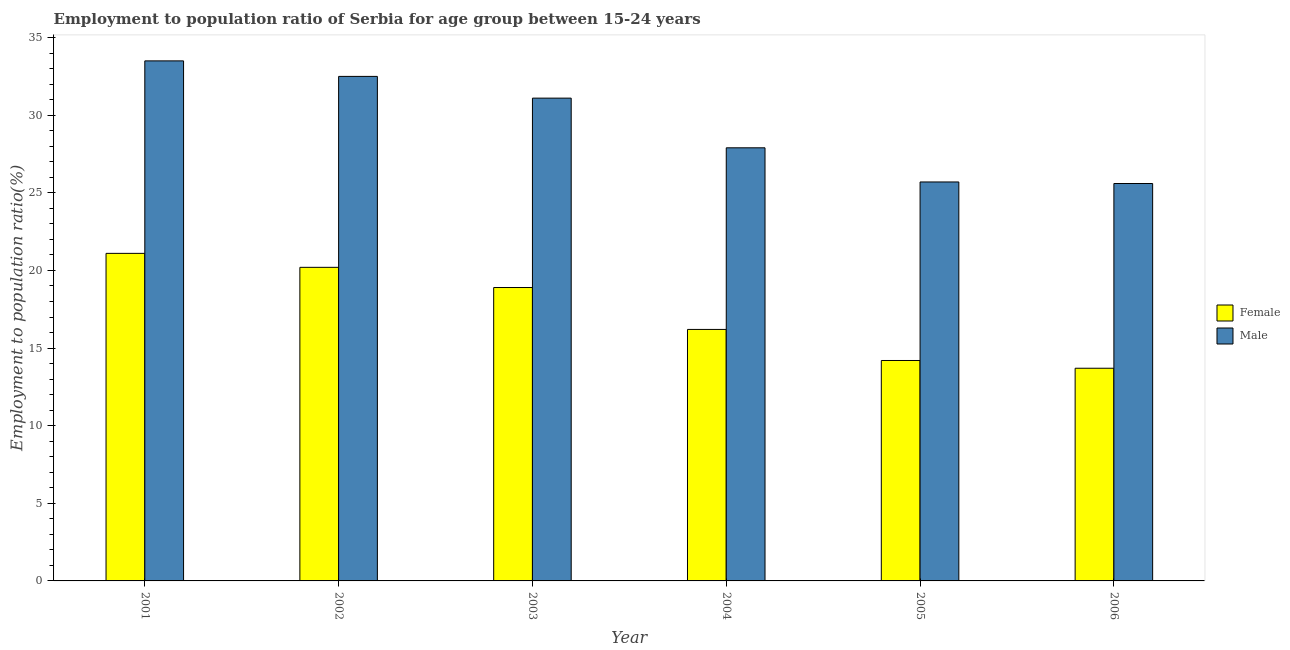Are the number of bars per tick equal to the number of legend labels?
Offer a terse response. Yes. Are the number of bars on each tick of the X-axis equal?
Offer a very short reply. Yes. How many bars are there on the 3rd tick from the right?
Provide a succinct answer. 2. In how many cases, is the number of bars for a given year not equal to the number of legend labels?
Offer a terse response. 0. What is the employment to population ratio(female) in 2001?
Give a very brief answer. 21.1. Across all years, what is the maximum employment to population ratio(male)?
Your answer should be compact. 33.5. Across all years, what is the minimum employment to population ratio(male)?
Provide a short and direct response. 25.6. What is the total employment to population ratio(female) in the graph?
Your response must be concise. 104.3. What is the difference between the employment to population ratio(female) in 2005 and the employment to population ratio(male) in 2006?
Your response must be concise. 0.5. What is the average employment to population ratio(female) per year?
Offer a very short reply. 17.38. In the year 2001, what is the difference between the employment to population ratio(female) and employment to population ratio(male)?
Keep it short and to the point. 0. What is the ratio of the employment to population ratio(male) in 2001 to that in 2002?
Offer a terse response. 1.03. Is the employment to population ratio(male) in 2002 less than that in 2005?
Give a very brief answer. No. Is the difference between the employment to population ratio(male) in 2001 and 2002 greater than the difference between the employment to population ratio(female) in 2001 and 2002?
Keep it short and to the point. No. What is the difference between the highest and the second highest employment to population ratio(female)?
Keep it short and to the point. 0.9. What is the difference between the highest and the lowest employment to population ratio(male)?
Your answer should be compact. 7.9. Is the sum of the employment to population ratio(male) in 2003 and 2006 greater than the maximum employment to population ratio(female) across all years?
Give a very brief answer. Yes. What does the 1st bar from the left in 2001 represents?
Your answer should be very brief. Female. Does the graph contain any zero values?
Your answer should be very brief. No. Does the graph contain grids?
Your answer should be compact. No. How are the legend labels stacked?
Offer a terse response. Vertical. What is the title of the graph?
Provide a succinct answer. Employment to population ratio of Serbia for age group between 15-24 years. Does "GDP" appear as one of the legend labels in the graph?
Offer a terse response. No. What is the label or title of the X-axis?
Ensure brevity in your answer.  Year. What is the Employment to population ratio(%) in Female in 2001?
Ensure brevity in your answer.  21.1. What is the Employment to population ratio(%) of Male in 2001?
Offer a very short reply. 33.5. What is the Employment to population ratio(%) in Female in 2002?
Your answer should be very brief. 20.2. What is the Employment to population ratio(%) of Male in 2002?
Provide a succinct answer. 32.5. What is the Employment to population ratio(%) of Female in 2003?
Provide a short and direct response. 18.9. What is the Employment to population ratio(%) in Male in 2003?
Offer a very short reply. 31.1. What is the Employment to population ratio(%) of Female in 2004?
Your answer should be compact. 16.2. What is the Employment to population ratio(%) in Male in 2004?
Provide a succinct answer. 27.9. What is the Employment to population ratio(%) in Female in 2005?
Provide a short and direct response. 14.2. What is the Employment to population ratio(%) of Male in 2005?
Offer a very short reply. 25.7. What is the Employment to population ratio(%) of Female in 2006?
Your response must be concise. 13.7. What is the Employment to population ratio(%) in Male in 2006?
Ensure brevity in your answer.  25.6. Across all years, what is the maximum Employment to population ratio(%) of Female?
Offer a terse response. 21.1. Across all years, what is the maximum Employment to population ratio(%) in Male?
Ensure brevity in your answer.  33.5. Across all years, what is the minimum Employment to population ratio(%) in Female?
Offer a very short reply. 13.7. Across all years, what is the minimum Employment to population ratio(%) in Male?
Offer a very short reply. 25.6. What is the total Employment to population ratio(%) of Female in the graph?
Offer a terse response. 104.3. What is the total Employment to population ratio(%) in Male in the graph?
Make the answer very short. 176.3. What is the difference between the Employment to population ratio(%) of Male in 2001 and that in 2002?
Your answer should be very brief. 1. What is the difference between the Employment to population ratio(%) of Male in 2001 and that in 2003?
Keep it short and to the point. 2.4. What is the difference between the Employment to population ratio(%) of Male in 2001 and that in 2004?
Offer a very short reply. 5.6. What is the difference between the Employment to population ratio(%) of Female in 2002 and that in 2003?
Your response must be concise. 1.3. What is the difference between the Employment to population ratio(%) of Male in 2002 and that in 2003?
Offer a terse response. 1.4. What is the difference between the Employment to population ratio(%) of Female in 2002 and that in 2004?
Offer a very short reply. 4. What is the difference between the Employment to population ratio(%) of Male in 2002 and that in 2004?
Ensure brevity in your answer.  4.6. What is the difference between the Employment to population ratio(%) of Female in 2002 and that in 2005?
Your answer should be compact. 6. What is the difference between the Employment to population ratio(%) in Male in 2002 and that in 2005?
Provide a succinct answer. 6.8. What is the difference between the Employment to population ratio(%) of Female in 2002 and that in 2006?
Your answer should be compact. 6.5. What is the difference between the Employment to population ratio(%) of Female in 2003 and that in 2004?
Make the answer very short. 2.7. What is the difference between the Employment to population ratio(%) of Male in 2003 and that in 2004?
Your answer should be very brief. 3.2. What is the difference between the Employment to population ratio(%) of Male in 2003 and that in 2005?
Your answer should be compact. 5.4. What is the difference between the Employment to population ratio(%) of Female in 2003 and that in 2006?
Your answer should be compact. 5.2. What is the difference between the Employment to population ratio(%) of Male in 2003 and that in 2006?
Give a very brief answer. 5.5. What is the difference between the Employment to population ratio(%) in Female in 2005 and that in 2006?
Your answer should be compact. 0.5. What is the difference between the Employment to population ratio(%) in Female in 2001 and the Employment to population ratio(%) in Male in 2003?
Offer a terse response. -10. What is the difference between the Employment to population ratio(%) of Female in 2001 and the Employment to population ratio(%) of Male in 2004?
Offer a very short reply. -6.8. What is the difference between the Employment to population ratio(%) of Female in 2001 and the Employment to population ratio(%) of Male in 2005?
Keep it short and to the point. -4.6. What is the difference between the Employment to population ratio(%) in Female in 2001 and the Employment to population ratio(%) in Male in 2006?
Make the answer very short. -4.5. What is the difference between the Employment to population ratio(%) of Female in 2002 and the Employment to population ratio(%) of Male in 2003?
Give a very brief answer. -10.9. What is the difference between the Employment to population ratio(%) of Female in 2002 and the Employment to population ratio(%) of Male in 2004?
Make the answer very short. -7.7. What is the difference between the Employment to population ratio(%) in Female in 2002 and the Employment to population ratio(%) in Male in 2006?
Provide a short and direct response. -5.4. What is the difference between the Employment to population ratio(%) in Female in 2003 and the Employment to population ratio(%) in Male in 2004?
Provide a succinct answer. -9. What is the difference between the Employment to population ratio(%) of Female in 2003 and the Employment to population ratio(%) of Male in 2005?
Provide a short and direct response. -6.8. What is the difference between the Employment to population ratio(%) of Female in 2003 and the Employment to population ratio(%) of Male in 2006?
Ensure brevity in your answer.  -6.7. What is the difference between the Employment to population ratio(%) in Female in 2004 and the Employment to population ratio(%) in Male in 2005?
Make the answer very short. -9.5. What is the average Employment to population ratio(%) in Female per year?
Provide a short and direct response. 17.38. What is the average Employment to population ratio(%) in Male per year?
Offer a terse response. 29.38. In the year 2003, what is the difference between the Employment to population ratio(%) in Female and Employment to population ratio(%) in Male?
Your response must be concise. -12.2. In the year 2005, what is the difference between the Employment to population ratio(%) in Female and Employment to population ratio(%) in Male?
Make the answer very short. -11.5. What is the ratio of the Employment to population ratio(%) in Female in 2001 to that in 2002?
Your answer should be very brief. 1.04. What is the ratio of the Employment to population ratio(%) of Male in 2001 to that in 2002?
Offer a terse response. 1.03. What is the ratio of the Employment to population ratio(%) of Female in 2001 to that in 2003?
Ensure brevity in your answer.  1.12. What is the ratio of the Employment to population ratio(%) in Male in 2001 to that in 2003?
Your response must be concise. 1.08. What is the ratio of the Employment to population ratio(%) in Female in 2001 to that in 2004?
Provide a succinct answer. 1.3. What is the ratio of the Employment to population ratio(%) of Male in 2001 to that in 2004?
Your answer should be compact. 1.2. What is the ratio of the Employment to population ratio(%) in Female in 2001 to that in 2005?
Make the answer very short. 1.49. What is the ratio of the Employment to population ratio(%) in Male in 2001 to that in 2005?
Offer a very short reply. 1.3. What is the ratio of the Employment to population ratio(%) of Female in 2001 to that in 2006?
Give a very brief answer. 1.54. What is the ratio of the Employment to population ratio(%) of Male in 2001 to that in 2006?
Offer a very short reply. 1.31. What is the ratio of the Employment to population ratio(%) in Female in 2002 to that in 2003?
Give a very brief answer. 1.07. What is the ratio of the Employment to population ratio(%) of Male in 2002 to that in 2003?
Keep it short and to the point. 1.04. What is the ratio of the Employment to population ratio(%) of Female in 2002 to that in 2004?
Give a very brief answer. 1.25. What is the ratio of the Employment to population ratio(%) in Male in 2002 to that in 2004?
Offer a very short reply. 1.16. What is the ratio of the Employment to population ratio(%) in Female in 2002 to that in 2005?
Offer a terse response. 1.42. What is the ratio of the Employment to population ratio(%) of Male in 2002 to that in 2005?
Provide a succinct answer. 1.26. What is the ratio of the Employment to population ratio(%) of Female in 2002 to that in 2006?
Offer a terse response. 1.47. What is the ratio of the Employment to population ratio(%) of Male in 2002 to that in 2006?
Offer a very short reply. 1.27. What is the ratio of the Employment to population ratio(%) in Female in 2003 to that in 2004?
Offer a very short reply. 1.17. What is the ratio of the Employment to population ratio(%) in Male in 2003 to that in 2004?
Offer a very short reply. 1.11. What is the ratio of the Employment to population ratio(%) in Female in 2003 to that in 2005?
Make the answer very short. 1.33. What is the ratio of the Employment to population ratio(%) in Male in 2003 to that in 2005?
Your answer should be compact. 1.21. What is the ratio of the Employment to population ratio(%) of Female in 2003 to that in 2006?
Provide a succinct answer. 1.38. What is the ratio of the Employment to population ratio(%) in Male in 2003 to that in 2006?
Your answer should be compact. 1.21. What is the ratio of the Employment to population ratio(%) of Female in 2004 to that in 2005?
Provide a succinct answer. 1.14. What is the ratio of the Employment to population ratio(%) of Male in 2004 to that in 2005?
Offer a terse response. 1.09. What is the ratio of the Employment to population ratio(%) of Female in 2004 to that in 2006?
Your answer should be very brief. 1.18. What is the ratio of the Employment to population ratio(%) of Male in 2004 to that in 2006?
Ensure brevity in your answer.  1.09. What is the ratio of the Employment to population ratio(%) of Female in 2005 to that in 2006?
Make the answer very short. 1.04. What is the difference between the highest and the second highest Employment to population ratio(%) in Male?
Make the answer very short. 1. 